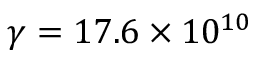Convert formula to latex. <formula><loc_0><loc_0><loc_500><loc_500>\gamma = 1 7 . 6 \times 1 0 ^ { 1 0 }</formula> 